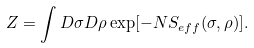<formula> <loc_0><loc_0><loc_500><loc_500>Z = \int D \sigma D \rho \exp [ - N S _ { e f f } ( \sigma , \rho ) ] .</formula> 